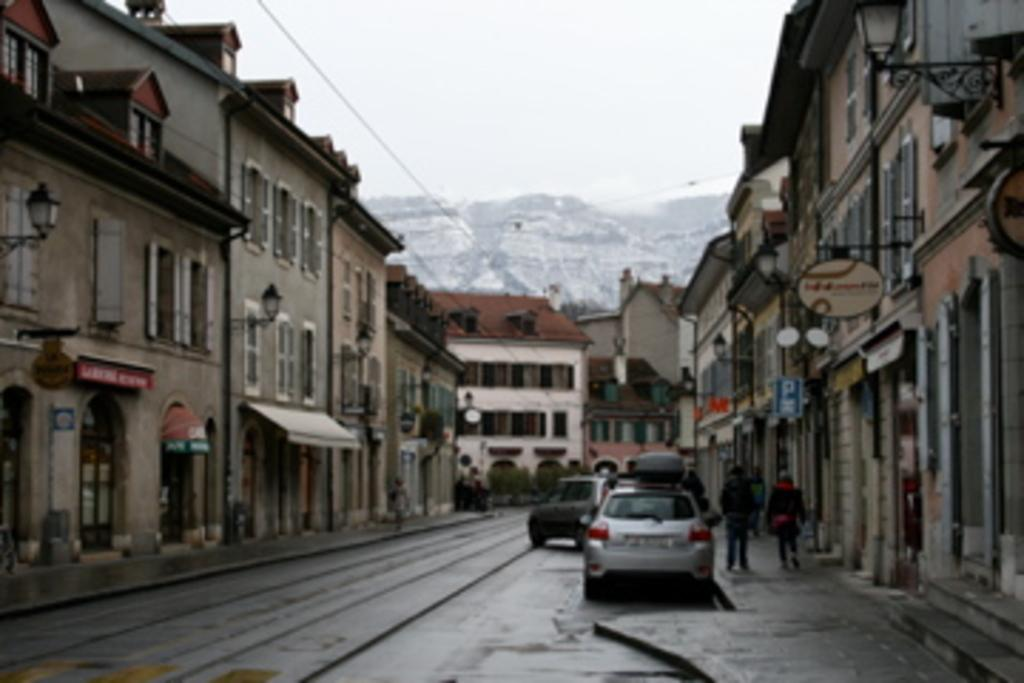What can be seen moving on the road in the image? There are vehicles on the road in the image. What type of structures are present in the image? There are buildings in the image. Can you identify any living beings in the image? Yes, there are people in the image. What other objects can be seen in the image besides vehicles and buildings? There are boards and plants in the image. What is visible in the background of the image? The sky is visible in the background of the image. Where is the fork used for eating in the image? There is no fork present in the image. What type of trees can be seen in the image? There are no trees present in the image. 